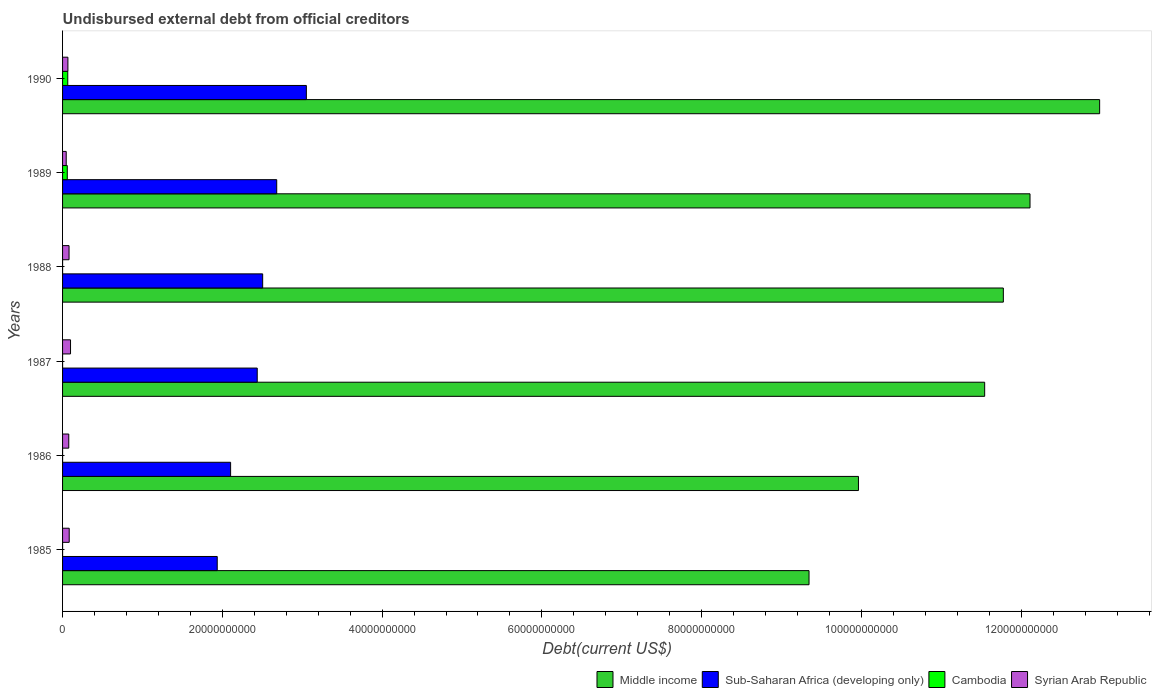How many groups of bars are there?
Your answer should be very brief. 6. Are the number of bars per tick equal to the number of legend labels?
Provide a succinct answer. Yes. How many bars are there on the 3rd tick from the top?
Offer a terse response. 4. What is the label of the 6th group of bars from the top?
Provide a succinct answer. 1985. What is the total debt in Cambodia in 1985?
Keep it short and to the point. 1.03e+06. Across all years, what is the maximum total debt in Middle income?
Your answer should be very brief. 1.30e+11. Across all years, what is the minimum total debt in Middle income?
Offer a very short reply. 9.34e+1. In which year was the total debt in Cambodia maximum?
Ensure brevity in your answer.  1990. In which year was the total debt in Middle income minimum?
Ensure brevity in your answer.  1985. What is the total total debt in Syrian Arab Republic in the graph?
Your answer should be very brief. 4.54e+09. What is the difference between the total debt in Syrian Arab Republic in 1989 and that in 1990?
Make the answer very short. -2.12e+08. What is the difference between the total debt in Sub-Saharan Africa (developing only) in 1990 and the total debt in Middle income in 1987?
Give a very brief answer. -8.49e+1. What is the average total debt in Middle income per year?
Offer a terse response. 1.13e+11. In the year 1987, what is the difference between the total debt in Cambodia and total debt in Sub-Saharan Africa (developing only)?
Keep it short and to the point. -2.44e+1. In how many years, is the total debt in Cambodia greater than 96000000000 US$?
Ensure brevity in your answer.  0. What is the ratio of the total debt in Middle income in 1985 to that in 1986?
Provide a succinct answer. 0.94. Is the total debt in Sub-Saharan Africa (developing only) in 1986 less than that in 1990?
Your answer should be compact. Yes. Is the difference between the total debt in Cambodia in 1985 and 1988 greater than the difference between the total debt in Sub-Saharan Africa (developing only) in 1985 and 1988?
Ensure brevity in your answer.  Yes. What is the difference between the highest and the second highest total debt in Cambodia?
Your answer should be very brief. 6.14e+07. What is the difference between the highest and the lowest total debt in Middle income?
Provide a short and direct response. 3.64e+1. Is the sum of the total debt in Cambodia in 1988 and 1989 greater than the maximum total debt in Sub-Saharan Africa (developing only) across all years?
Your answer should be very brief. No. Is it the case that in every year, the sum of the total debt in Sub-Saharan Africa (developing only) and total debt in Syrian Arab Republic is greater than the sum of total debt in Middle income and total debt in Cambodia?
Your answer should be very brief. No. What does the 4th bar from the top in 1985 represents?
Your answer should be compact. Middle income. What does the 3rd bar from the bottom in 1986 represents?
Provide a short and direct response. Cambodia. How many bars are there?
Ensure brevity in your answer.  24. Are all the bars in the graph horizontal?
Offer a terse response. Yes. What is the difference between two consecutive major ticks on the X-axis?
Offer a very short reply. 2.00e+1. Where does the legend appear in the graph?
Your answer should be very brief. Bottom right. How many legend labels are there?
Your response must be concise. 4. What is the title of the graph?
Your response must be concise. Undisbursed external debt from official creditors. Does "Sudan" appear as one of the legend labels in the graph?
Your answer should be compact. No. What is the label or title of the X-axis?
Ensure brevity in your answer.  Debt(current US$). What is the label or title of the Y-axis?
Offer a terse response. Years. What is the Debt(current US$) of Middle income in 1985?
Provide a succinct answer. 9.34e+1. What is the Debt(current US$) of Sub-Saharan Africa (developing only) in 1985?
Ensure brevity in your answer.  1.94e+1. What is the Debt(current US$) in Cambodia in 1985?
Provide a short and direct response. 1.03e+06. What is the Debt(current US$) in Syrian Arab Republic in 1985?
Your response must be concise. 8.31e+08. What is the Debt(current US$) of Middle income in 1986?
Offer a very short reply. 9.96e+1. What is the Debt(current US$) of Sub-Saharan Africa (developing only) in 1986?
Make the answer very short. 2.10e+1. What is the Debt(current US$) of Cambodia in 1986?
Keep it short and to the point. 1.03e+06. What is the Debt(current US$) of Syrian Arab Republic in 1986?
Offer a very short reply. 7.76e+08. What is the Debt(current US$) in Middle income in 1987?
Your answer should be very brief. 1.15e+11. What is the Debt(current US$) of Sub-Saharan Africa (developing only) in 1987?
Make the answer very short. 2.44e+1. What is the Debt(current US$) of Cambodia in 1987?
Provide a short and direct response. 1.03e+06. What is the Debt(current US$) of Syrian Arab Republic in 1987?
Provide a succinct answer. 9.97e+08. What is the Debt(current US$) in Middle income in 1988?
Keep it short and to the point. 1.18e+11. What is the Debt(current US$) of Sub-Saharan Africa (developing only) in 1988?
Your answer should be very brief. 2.50e+1. What is the Debt(current US$) in Cambodia in 1988?
Provide a short and direct response. 1.03e+06. What is the Debt(current US$) in Syrian Arab Republic in 1988?
Give a very brief answer. 8.11e+08. What is the Debt(current US$) in Middle income in 1989?
Ensure brevity in your answer.  1.21e+11. What is the Debt(current US$) of Sub-Saharan Africa (developing only) in 1989?
Provide a short and direct response. 2.68e+1. What is the Debt(current US$) of Cambodia in 1989?
Provide a succinct answer. 5.90e+08. What is the Debt(current US$) of Syrian Arab Republic in 1989?
Your answer should be compact. 4.57e+08. What is the Debt(current US$) of Middle income in 1990?
Make the answer very short. 1.30e+11. What is the Debt(current US$) of Sub-Saharan Africa (developing only) in 1990?
Your answer should be very brief. 3.05e+1. What is the Debt(current US$) of Cambodia in 1990?
Your response must be concise. 6.51e+08. What is the Debt(current US$) in Syrian Arab Republic in 1990?
Give a very brief answer. 6.69e+08. Across all years, what is the maximum Debt(current US$) in Middle income?
Provide a short and direct response. 1.30e+11. Across all years, what is the maximum Debt(current US$) in Sub-Saharan Africa (developing only)?
Offer a very short reply. 3.05e+1. Across all years, what is the maximum Debt(current US$) in Cambodia?
Your response must be concise. 6.51e+08. Across all years, what is the maximum Debt(current US$) in Syrian Arab Republic?
Provide a short and direct response. 9.97e+08. Across all years, what is the minimum Debt(current US$) of Middle income?
Ensure brevity in your answer.  9.34e+1. Across all years, what is the minimum Debt(current US$) in Sub-Saharan Africa (developing only)?
Ensure brevity in your answer.  1.94e+1. Across all years, what is the minimum Debt(current US$) in Cambodia?
Provide a short and direct response. 1.03e+06. Across all years, what is the minimum Debt(current US$) in Syrian Arab Republic?
Make the answer very short. 4.57e+08. What is the total Debt(current US$) in Middle income in the graph?
Your response must be concise. 6.77e+11. What is the total Debt(current US$) of Sub-Saharan Africa (developing only) in the graph?
Provide a succinct answer. 1.47e+11. What is the total Debt(current US$) in Cambodia in the graph?
Your response must be concise. 1.24e+09. What is the total Debt(current US$) of Syrian Arab Republic in the graph?
Keep it short and to the point. 4.54e+09. What is the difference between the Debt(current US$) of Middle income in 1985 and that in 1986?
Keep it short and to the point. -6.19e+09. What is the difference between the Debt(current US$) of Sub-Saharan Africa (developing only) in 1985 and that in 1986?
Make the answer very short. -1.67e+09. What is the difference between the Debt(current US$) in Syrian Arab Republic in 1985 and that in 1986?
Provide a succinct answer. 5.51e+07. What is the difference between the Debt(current US$) of Middle income in 1985 and that in 1987?
Your response must be concise. -2.20e+1. What is the difference between the Debt(current US$) of Sub-Saharan Africa (developing only) in 1985 and that in 1987?
Give a very brief answer. -5.01e+09. What is the difference between the Debt(current US$) of Syrian Arab Republic in 1985 and that in 1987?
Make the answer very short. -1.66e+08. What is the difference between the Debt(current US$) in Middle income in 1985 and that in 1988?
Your answer should be compact. -2.43e+1. What is the difference between the Debt(current US$) in Sub-Saharan Africa (developing only) in 1985 and that in 1988?
Make the answer very short. -5.69e+09. What is the difference between the Debt(current US$) in Syrian Arab Republic in 1985 and that in 1988?
Your response must be concise. 2.02e+07. What is the difference between the Debt(current US$) of Middle income in 1985 and that in 1989?
Offer a terse response. -2.77e+1. What is the difference between the Debt(current US$) in Sub-Saharan Africa (developing only) in 1985 and that in 1989?
Give a very brief answer. -7.45e+09. What is the difference between the Debt(current US$) of Cambodia in 1985 and that in 1989?
Your answer should be very brief. -5.89e+08. What is the difference between the Debt(current US$) in Syrian Arab Republic in 1985 and that in 1989?
Ensure brevity in your answer.  3.75e+08. What is the difference between the Debt(current US$) of Middle income in 1985 and that in 1990?
Keep it short and to the point. -3.64e+1. What is the difference between the Debt(current US$) of Sub-Saharan Africa (developing only) in 1985 and that in 1990?
Offer a very short reply. -1.12e+1. What is the difference between the Debt(current US$) of Cambodia in 1985 and that in 1990?
Give a very brief answer. -6.50e+08. What is the difference between the Debt(current US$) in Syrian Arab Republic in 1985 and that in 1990?
Give a very brief answer. 1.62e+08. What is the difference between the Debt(current US$) of Middle income in 1986 and that in 1987?
Your answer should be very brief. -1.58e+1. What is the difference between the Debt(current US$) of Sub-Saharan Africa (developing only) in 1986 and that in 1987?
Your response must be concise. -3.33e+09. What is the difference between the Debt(current US$) of Cambodia in 1986 and that in 1987?
Ensure brevity in your answer.  0. What is the difference between the Debt(current US$) of Syrian Arab Republic in 1986 and that in 1987?
Keep it short and to the point. -2.21e+08. What is the difference between the Debt(current US$) in Middle income in 1986 and that in 1988?
Provide a succinct answer. -1.81e+1. What is the difference between the Debt(current US$) in Sub-Saharan Africa (developing only) in 1986 and that in 1988?
Provide a short and direct response. -4.01e+09. What is the difference between the Debt(current US$) of Cambodia in 1986 and that in 1988?
Give a very brief answer. 0. What is the difference between the Debt(current US$) in Syrian Arab Republic in 1986 and that in 1988?
Your answer should be very brief. -3.49e+07. What is the difference between the Debt(current US$) in Middle income in 1986 and that in 1989?
Offer a terse response. -2.15e+1. What is the difference between the Debt(current US$) of Sub-Saharan Africa (developing only) in 1986 and that in 1989?
Offer a terse response. -5.77e+09. What is the difference between the Debt(current US$) in Cambodia in 1986 and that in 1989?
Keep it short and to the point. -5.89e+08. What is the difference between the Debt(current US$) in Syrian Arab Republic in 1986 and that in 1989?
Your response must be concise. 3.20e+08. What is the difference between the Debt(current US$) of Middle income in 1986 and that in 1990?
Provide a succinct answer. -3.02e+1. What is the difference between the Debt(current US$) in Sub-Saharan Africa (developing only) in 1986 and that in 1990?
Give a very brief answer. -9.48e+09. What is the difference between the Debt(current US$) in Cambodia in 1986 and that in 1990?
Your answer should be compact. -6.50e+08. What is the difference between the Debt(current US$) in Syrian Arab Republic in 1986 and that in 1990?
Ensure brevity in your answer.  1.07e+08. What is the difference between the Debt(current US$) of Middle income in 1987 and that in 1988?
Offer a very short reply. -2.34e+09. What is the difference between the Debt(current US$) in Sub-Saharan Africa (developing only) in 1987 and that in 1988?
Make the answer very short. -6.80e+08. What is the difference between the Debt(current US$) in Syrian Arab Republic in 1987 and that in 1988?
Ensure brevity in your answer.  1.86e+08. What is the difference between the Debt(current US$) in Middle income in 1987 and that in 1989?
Your response must be concise. -5.68e+09. What is the difference between the Debt(current US$) of Sub-Saharan Africa (developing only) in 1987 and that in 1989?
Your answer should be compact. -2.44e+09. What is the difference between the Debt(current US$) of Cambodia in 1987 and that in 1989?
Make the answer very short. -5.89e+08. What is the difference between the Debt(current US$) of Syrian Arab Republic in 1987 and that in 1989?
Keep it short and to the point. 5.40e+08. What is the difference between the Debt(current US$) of Middle income in 1987 and that in 1990?
Your response must be concise. -1.44e+1. What is the difference between the Debt(current US$) of Sub-Saharan Africa (developing only) in 1987 and that in 1990?
Provide a short and direct response. -6.15e+09. What is the difference between the Debt(current US$) in Cambodia in 1987 and that in 1990?
Make the answer very short. -6.50e+08. What is the difference between the Debt(current US$) of Syrian Arab Republic in 1987 and that in 1990?
Give a very brief answer. 3.28e+08. What is the difference between the Debt(current US$) in Middle income in 1988 and that in 1989?
Offer a terse response. -3.34e+09. What is the difference between the Debt(current US$) of Sub-Saharan Africa (developing only) in 1988 and that in 1989?
Make the answer very short. -1.76e+09. What is the difference between the Debt(current US$) of Cambodia in 1988 and that in 1989?
Provide a succinct answer. -5.89e+08. What is the difference between the Debt(current US$) of Syrian Arab Republic in 1988 and that in 1989?
Your answer should be compact. 3.54e+08. What is the difference between the Debt(current US$) of Middle income in 1988 and that in 1990?
Your answer should be compact. -1.21e+1. What is the difference between the Debt(current US$) in Sub-Saharan Africa (developing only) in 1988 and that in 1990?
Your answer should be compact. -5.47e+09. What is the difference between the Debt(current US$) in Cambodia in 1988 and that in 1990?
Ensure brevity in your answer.  -6.50e+08. What is the difference between the Debt(current US$) of Syrian Arab Republic in 1988 and that in 1990?
Provide a short and direct response. 1.42e+08. What is the difference between the Debt(current US$) of Middle income in 1989 and that in 1990?
Provide a short and direct response. -8.72e+09. What is the difference between the Debt(current US$) in Sub-Saharan Africa (developing only) in 1989 and that in 1990?
Provide a succinct answer. -3.71e+09. What is the difference between the Debt(current US$) of Cambodia in 1989 and that in 1990?
Keep it short and to the point. -6.14e+07. What is the difference between the Debt(current US$) in Syrian Arab Republic in 1989 and that in 1990?
Your answer should be very brief. -2.12e+08. What is the difference between the Debt(current US$) of Middle income in 1985 and the Debt(current US$) of Sub-Saharan Africa (developing only) in 1986?
Offer a terse response. 7.24e+1. What is the difference between the Debt(current US$) of Middle income in 1985 and the Debt(current US$) of Cambodia in 1986?
Offer a terse response. 9.34e+1. What is the difference between the Debt(current US$) of Middle income in 1985 and the Debt(current US$) of Syrian Arab Republic in 1986?
Keep it short and to the point. 9.27e+1. What is the difference between the Debt(current US$) in Sub-Saharan Africa (developing only) in 1985 and the Debt(current US$) in Cambodia in 1986?
Provide a succinct answer. 1.94e+1. What is the difference between the Debt(current US$) of Sub-Saharan Africa (developing only) in 1985 and the Debt(current US$) of Syrian Arab Republic in 1986?
Your answer should be compact. 1.86e+1. What is the difference between the Debt(current US$) of Cambodia in 1985 and the Debt(current US$) of Syrian Arab Republic in 1986?
Offer a very short reply. -7.75e+08. What is the difference between the Debt(current US$) of Middle income in 1985 and the Debt(current US$) of Sub-Saharan Africa (developing only) in 1987?
Your answer should be compact. 6.91e+1. What is the difference between the Debt(current US$) of Middle income in 1985 and the Debt(current US$) of Cambodia in 1987?
Provide a succinct answer. 9.34e+1. What is the difference between the Debt(current US$) in Middle income in 1985 and the Debt(current US$) in Syrian Arab Republic in 1987?
Offer a terse response. 9.24e+1. What is the difference between the Debt(current US$) in Sub-Saharan Africa (developing only) in 1985 and the Debt(current US$) in Cambodia in 1987?
Make the answer very short. 1.94e+1. What is the difference between the Debt(current US$) in Sub-Saharan Africa (developing only) in 1985 and the Debt(current US$) in Syrian Arab Republic in 1987?
Provide a succinct answer. 1.84e+1. What is the difference between the Debt(current US$) of Cambodia in 1985 and the Debt(current US$) of Syrian Arab Republic in 1987?
Your response must be concise. -9.96e+08. What is the difference between the Debt(current US$) in Middle income in 1985 and the Debt(current US$) in Sub-Saharan Africa (developing only) in 1988?
Ensure brevity in your answer.  6.84e+1. What is the difference between the Debt(current US$) in Middle income in 1985 and the Debt(current US$) in Cambodia in 1988?
Offer a terse response. 9.34e+1. What is the difference between the Debt(current US$) of Middle income in 1985 and the Debt(current US$) of Syrian Arab Republic in 1988?
Your answer should be compact. 9.26e+1. What is the difference between the Debt(current US$) in Sub-Saharan Africa (developing only) in 1985 and the Debt(current US$) in Cambodia in 1988?
Provide a succinct answer. 1.94e+1. What is the difference between the Debt(current US$) of Sub-Saharan Africa (developing only) in 1985 and the Debt(current US$) of Syrian Arab Republic in 1988?
Ensure brevity in your answer.  1.86e+1. What is the difference between the Debt(current US$) of Cambodia in 1985 and the Debt(current US$) of Syrian Arab Republic in 1988?
Your answer should be compact. -8.10e+08. What is the difference between the Debt(current US$) of Middle income in 1985 and the Debt(current US$) of Sub-Saharan Africa (developing only) in 1989?
Make the answer very short. 6.66e+1. What is the difference between the Debt(current US$) in Middle income in 1985 and the Debt(current US$) in Cambodia in 1989?
Your response must be concise. 9.29e+1. What is the difference between the Debt(current US$) in Middle income in 1985 and the Debt(current US$) in Syrian Arab Republic in 1989?
Provide a succinct answer. 9.30e+1. What is the difference between the Debt(current US$) of Sub-Saharan Africa (developing only) in 1985 and the Debt(current US$) of Cambodia in 1989?
Ensure brevity in your answer.  1.88e+1. What is the difference between the Debt(current US$) of Sub-Saharan Africa (developing only) in 1985 and the Debt(current US$) of Syrian Arab Republic in 1989?
Ensure brevity in your answer.  1.89e+1. What is the difference between the Debt(current US$) of Cambodia in 1985 and the Debt(current US$) of Syrian Arab Republic in 1989?
Provide a succinct answer. -4.56e+08. What is the difference between the Debt(current US$) in Middle income in 1985 and the Debt(current US$) in Sub-Saharan Africa (developing only) in 1990?
Your answer should be compact. 6.29e+1. What is the difference between the Debt(current US$) of Middle income in 1985 and the Debt(current US$) of Cambodia in 1990?
Provide a short and direct response. 9.28e+1. What is the difference between the Debt(current US$) of Middle income in 1985 and the Debt(current US$) of Syrian Arab Republic in 1990?
Provide a succinct answer. 9.28e+1. What is the difference between the Debt(current US$) of Sub-Saharan Africa (developing only) in 1985 and the Debt(current US$) of Cambodia in 1990?
Offer a terse response. 1.87e+1. What is the difference between the Debt(current US$) of Sub-Saharan Africa (developing only) in 1985 and the Debt(current US$) of Syrian Arab Republic in 1990?
Keep it short and to the point. 1.87e+1. What is the difference between the Debt(current US$) in Cambodia in 1985 and the Debt(current US$) in Syrian Arab Republic in 1990?
Ensure brevity in your answer.  -6.68e+08. What is the difference between the Debt(current US$) of Middle income in 1986 and the Debt(current US$) of Sub-Saharan Africa (developing only) in 1987?
Offer a terse response. 7.53e+1. What is the difference between the Debt(current US$) in Middle income in 1986 and the Debt(current US$) in Cambodia in 1987?
Ensure brevity in your answer.  9.96e+1. What is the difference between the Debt(current US$) in Middle income in 1986 and the Debt(current US$) in Syrian Arab Republic in 1987?
Ensure brevity in your answer.  9.86e+1. What is the difference between the Debt(current US$) of Sub-Saharan Africa (developing only) in 1986 and the Debt(current US$) of Cambodia in 1987?
Make the answer very short. 2.10e+1. What is the difference between the Debt(current US$) of Sub-Saharan Africa (developing only) in 1986 and the Debt(current US$) of Syrian Arab Republic in 1987?
Make the answer very short. 2.00e+1. What is the difference between the Debt(current US$) in Cambodia in 1986 and the Debt(current US$) in Syrian Arab Republic in 1987?
Make the answer very short. -9.96e+08. What is the difference between the Debt(current US$) in Middle income in 1986 and the Debt(current US$) in Sub-Saharan Africa (developing only) in 1988?
Offer a terse response. 7.46e+1. What is the difference between the Debt(current US$) of Middle income in 1986 and the Debt(current US$) of Cambodia in 1988?
Offer a terse response. 9.96e+1. What is the difference between the Debt(current US$) in Middle income in 1986 and the Debt(current US$) in Syrian Arab Republic in 1988?
Ensure brevity in your answer.  9.88e+1. What is the difference between the Debt(current US$) in Sub-Saharan Africa (developing only) in 1986 and the Debt(current US$) in Cambodia in 1988?
Keep it short and to the point. 2.10e+1. What is the difference between the Debt(current US$) of Sub-Saharan Africa (developing only) in 1986 and the Debt(current US$) of Syrian Arab Republic in 1988?
Keep it short and to the point. 2.02e+1. What is the difference between the Debt(current US$) of Cambodia in 1986 and the Debt(current US$) of Syrian Arab Republic in 1988?
Offer a very short reply. -8.10e+08. What is the difference between the Debt(current US$) in Middle income in 1986 and the Debt(current US$) in Sub-Saharan Africa (developing only) in 1989?
Make the answer very short. 7.28e+1. What is the difference between the Debt(current US$) of Middle income in 1986 and the Debt(current US$) of Cambodia in 1989?
Provide a succinct answer. 9.90e+1. What is the difference between the Debt(current US$) of Middle income in 1986 and the Debt(current US$) of Syrian Arab Republic in 1989?
Offer a terse response. 9.92e+1. What is the difference between the Debt(current US$) of Sub-Saharan Africa (developing only) in 1986 and the Debt(current US$) of Cambodia in 1989?
Your answer should be very brief. 2.04e+1. What is the difference between the Debt(current US$) of Sub-Saharan Africa (developing only) in 1986 and the Debt(current US$) of Syrian Arab Republic in 1989?
Offer a terse response. 2.06e+1. What is the difference between the Debt(current US$) of Cambodia in 1986 and the Debt(current US$) of Syrian Arab Republic in 1989?
Make the answer very short. -4.56e+08. What is the difference between the Debt(current US$) of Middle income in 1986 and the Debt(current US$) of Sub-Saharan Africa (developing only) in 1990?
Give a very brief answer. 6.91e+1. What is the difference between the Debt(current US$) of Middle income in 1986 and the Debt(current US$) of Cambodia in 1990?
Your answer should be very brief. 9.90e+1. What is the difference between the Debt(current US$) of Middle income in 1986 and the Debt(current US$) of Syrian Arab Republic in 1990?
Keep it short and to the point. 9.90e+1. What is the difference between the Debt(current US$) of Sub-Saharan Africa (developing only) in 1986 and the Debt(current US$) of Cambodia in 1990?
Provide a succinct answer. 2.04e+1. What is the difference between the Debt(current US$) of Sub-Saharan Africa (developing only) in 1986 and the Debt(current US$) of Syrian Arab Republic in 1990?
Your answer should be very brief. 2.04e+1. What is the difference between the Debt(current US$) of Cambodia in 1986 and the Debt(current US$) of Syrian Arab Republic in 1990?
Make the answer very short. -6.68e+08. What is the difference between the Debt(current US$) of Middle income in 1987 and the Debt(current US$) of Sub-Saharan Africa (developing only) in 1988?
Keep it short and to the point. 9.04e+1. What is the difference between the Debt(current US$) in Middle income in 1987 and the Debt(current US$) in Cambodia in 1988?
Make the answer very short. 1.15e+11. What is the difference between the Debt(current US$) of Middle income in 1987 and the Debt(current US$) of Syrian Arab Republic in 1988?
Ensure brevity in your answer.  1.15e+11. What is the difference between the Debt(current US$) of Sub-Saharan Africa (developing only) in 1987 and the Debt(current US$) of Cambodia in 1988?
Ensure brevity in your answer.  2.44e+1. What is the difference between the Debt(current US$) of Sub-Saharan Africa (developing only) in 1987 and the Debt(current US$) of Syrian Arab Republic in 1988?
Provide a short and direct response. 2.36e+1. What is the difference between the Debt(current US$) of Cambodia in 1987 and the Debt(current US$) of Syrian Arab Republic in 1988?
Offer a terse response. -8.10e+08. What is the difference between the Debt(current US$) of Middle income in 1987 and the Debt(current US$) of Sub-Saharan Africa (developing only) in 1989?
Provide a short and direct response. 8.86e+1. What is the difference between the Debt(current US$) in Middle income in 1987 and the Debt(current US$) in Cambodia in 1989?
Keep it short and to the point. 1.15e+11. What is the difference between the Debt(current US$) in Middle income in 1987 and the Debt(current US$) in Syrian Arab Republic in 1989?
Provide a short and direct response. 1.15e+11. What is the difference between the Debt(current US$) of Sub-Saharan Africa (developing only) in 1987 and the Debt(current US$) of Cambodia in 1989?
Provide a short and direct response. 2.38e+1. What is the difference between the Debt(current US$) in Sub-Saharan Africa (developing only) in 1987 and the Debt(current US$) in Syrian Arab Republic in 1989?
Provide a short and direct response. 2.39e+1. What is the difference between the Debt(current US$) in Cambodia in 1987 and the Debt(current US$) in Syrian Arab Republic in 1989?
Offer a terse response. -4.56e+08. What is the difference between the Debt(current US$) in Middle income in 1987 and the Debt(current US$) in Sub-Saharan Africa (developing only) in 1990?
Give a very brief answer. 8.49e+1. What is the difference between the Debt(current US$) of Middle income in 1987 and the Debt(current US$) of Cambodia in 1990?
Provide a succinct answer. 1.15e+11. What is the difference between the Debt(current US$) of Middle income in 1987 and the Debt(current US$) of Syrian Arab Republic in 1990?
Ensure brevity in your answer.  1.15e+11. What is the difference between the Debt(current US$) in Sub-Saharan Africa (developing only) in 1987 and the Debt(current US$) in Cambodia in 1990?
Make the answer very short. 2.37e+1. What is the difference between the Debt(current US$) of Sub-Saharan Africa (developing only) in 1987 and the Debt(current US$) of Syrian Arab Republic in 1990?
Offer a very short reply. 2.37e+1. What is the difference between the Debt(current US$) in Cambodia in 1987 and the Debt(current US$) in Syrian Arab Republic in 1990?
Give a very brief answer. -6.68e+08. What is the difference between the Debt(current US$) of Middle income in 1988 and the Debt(current US$) of Sub-Saharan Africa (developing only) in 1989?
Make the answer very short. 9.10e+1. What is the difference between the Debt(current US$) of Middle income in 1988 and the Debt(current US$) of Cambodia in 1989?
Ensure brevity in your answer.  1.17e+11. What is the difference between the Debt(current US$) of Middle income in 1988 and the Debt(current US$) of Syrian Arab Republic in 1989?
Keep it short and to the point. 1.17e+11. What is the difference between the Debt(current US$) of Sub-Saharan Africa (developing only) in 1988 and the Debt(current US$) of Cambodia in 1989?
Provide a succinct answer. 2.45e+1. What is the difference between the Debt(current US$) of Sub-Saharan Africa (developing only) in 1988 and the Debt(current US$) of Syrian Arab Republic in 1989?
Give a very brief answer. 2.46e+1. What is the difference between the Debt(current US$) of Cambodia in 1988 and the Debt(current US$) of Syrian Arab Republic in 1989?
Provide a short and direct response. -4.56e+08. What is the difference between the Debt(current US$) in Middle income in 1988 and the Debt(current US$) in Sub-Saharan Africa (developing only) in 1990?
Your answer should be compact. 8.72e+1. What is the difference between the Debt(current US$) in Middle income in 1988 and the Debt(current US$) in Cambodia in 1990?
Your answer should be compact. 1.17e+11. What is the difference between the Debt(current US$) of Middle income in 1988 and the Debt(current US$) of Syrian Arab Republic in 1990?
Ensure brevity in your answer.  1.17e+11. What is the difference between the Debt(current US$) of Sub-Saharan Africa (developing only) in 1988 and the Debt(current US$) of Cambodia in 1990?
Your response must be concise. 2.44e+1. What is the difference between the Debt(current US$) in Sub-Saharan Africa (developing only) in 1988 and the Debt(current US$) in Syrian Arab Republic in 1990?
Keep it short and to the point. 2.44e+1. What is the difference between the Debt(current US$) in Cambodia in 1988 and the Debt(current US$) in Syrian Arab Republic in 1990?
Offer a terse response. -6.68e+08. What is the difference between the Debt(current US$) in Middle income in 1989 and the Debt(current US$) in Sub-Saharan Africa (developing only) in 1990?
Provide a succinct answer. 9.06e+1. What is the difference between the Debt(current US$) in Middle income in 1989 and the Debt(current US$) in Cambodia in 1990?
Your answer should be compact. 1.20e+11. What is the difference between the Debt(current US$) of Middle income in 1989 and the Debt(current US$) of Syrian Arab Republic in 1990?
Give a very brief answer. 1.20e+11. What is the difference between the Debt(current US$) of Sub-Saharan Africa (developing only) in 1989 and the Debt(current US$) of Cambodia in 1990?
Make the answer very short. 2.62e+1. What is the difference between the Debt(current US$) of Sub-Saharan Africa (developing only) in 1989 and the Debt(current US$) of Syrian Arab Republic in 1990?
Make the answer very short. 2.61e+1. What is the difference between the Debt(current US$) of Cambodia in 1989 and the Debt(current US$) of Syrian Arab Republic in 1990?
Keep it short and to the point. -7.92e+07. What is the average Debt(current US$) in Middle income per year?
Ensure brevity in your answer.  1.13e+11. What is the average Debt(current US$) in Sub-Saharan Africa (developing only) per year?
Your answer should be compact. 2.45e+1. What is the average Debt(current US$) of Cambodia per year?
Provide a succinct answer. 2.07e+08. What is the average Debt(current US$) in Syrian Arab Republic per year?
Offer a very short reply. 7.57e+08. In the year 1985, what is the difference between the Debt(current US$) of Middle income and Debt(current US$) of Sub-Saharan Africa (developing only)?
Your response must be concise. 7.41e+1. In the year 1985, what is the difference between the Debt(current US$) of Middle income and Debt(current US$) of Cambodia?
Ensure brevity in your answer.  9.34e+1. In the year 1985, what is the difference between the Debt(current US$) of Middle income and Debt(current US$) of Syrian Arab Republic?
Provide a succinct answer. 9.26e+1. In the year 1985, what is the difference between the Debt(current US$) in Sub-Saharan Africa (developing only) and Debt(current US$) in Cambodia?
Your answer should be very brief. 1.94e+1. In the year 1985, what is the difference between the Debt(current US$) of Sub-Saharan Africa (developing only) and Debt(current US$) of Syrian Arab Republic?
Give a very brief answer. 1.85e+1. In the year 1985, what is the difference between the Debt(current US$) of Cambodia and Debt(current US$) of Syrian Arab Republic?
Your answer should be compact. -8.30e+08. In the year 1986, what is the difference between the Debt(current US$) of Middle income and Debt(current US$) of Sub-Saharan Africa (developing only)?
Your answer should be very brief. 7.86e+1. In the year 1986, what is the difference between the Debt(current US$) of Middle income and Debt(current US$) of Cambodia?
Keep it short and to the point. 9.96e+1. In the year 1986, what is the difference between the Debt(current US$) in Middle income and Debt(current US$) in Syrian Arab Republic?
Ensure brevity in your answer.  9.89e+1. In the year 1986, what is the difference between the Debt(current US$) in Sub-Saharan Africa (developing only) and Debt(current US$) in Cambodia?
Provide a succinct answer. 2.10e+1. In the year 1986, what is the difference between the Debt(current US$) of Sub-Saharan Africa (developing only) and Debt(current US$) of Syrian Arab Republic?
Provide a short and direct response. 2.03e+1. In the year 1986, what is the difference between the Debt(current US$) of Cambodia and Debt(current US$) of Syrian Arab Republic?
Provide a short and direct response. -7.75e+08. In the year 1987, what is the difference between the Debt(current US$) of Middle income and Debt(current US$) of Sub-Saharan Africa (developing only)?
Your response must be concise. 9.11e+1. In the year 1987, what is the difference between the Debt(current US$) of Middle income and Debt(current US$) of Cambodia?
Keep it short and to the point. 1.15e+11. In the year 1987, what is the difference between the Debt(current US$) in Middle income and Debt(current US$) in Syrian Arab Republic?
Give a very brief answer. 1.14e+11. In the year 1987, what is the difference between the Debt(current US$) in Sub-Saharan Africa (developing only) and Debt(current US$) in Cambodia?
Offer a terse response. 2.44e+1. In the year 1987, what is the difference between the Debt(current US$) of Sub-Saharan Africa (developing only) and Debt(current US$) of Syrian Arab Republic?
Your answer should be very brief. 2.34e+1. In the year 1987, what is the difference between the Debt(current US$) in Cambodia and Debt(current US$) in Syrian Arab Republic?
Make the answer very short. -9.96e+08. In the year 1988, what is the difference between the Debt(current US$) of Middle income and Debt(current US$) of Sub-Saharan Africa (developing only)?
Give a very brief answer. 9.27e+1. In the year 1988, what is the difference between the Debt(current US$) in Middle income and Debt(current US$) in Cambodia?
Offer a terse response. 1.18e+11. In the year 1988, what is the difference between the Debt(current US$) in Middle income and Debt(current US$) in Syrian Arab Republic?
Give a very brief answer. 1.17e+11. In the year 1988, what is the difference between the Debt(current US$) of Sub-Saharan Africa (developing only) and Debt(current US$) of Cambodia?
Keep it short and to the point. 2.50e+1. In the year 1988, what is the difference between the Debt(current US$) in Sub-Saharan Africa (developing only) and Debt(current US$) in Syrian Arab Republic?
Your answer should be very brief. 2.42e+1. In the year 1988, what is the difference between the Debt(current US$) in Cambodia and Debt(current US$) in Syrian Arab Republic?
Provide a short and direct response. -8.10e+08. In the year 1989, what is the difference between the Debt(current US$) of Middle income and Debt(current US$) of Sub-Saharan Africa (developing only)?
Give a very brief answer. 9.43e+1. In the year 1989, what is the difference between the Debt(current US$) in Middle income and Debt(current US$) in Cambodia?
Provide a succinct answer. 1.21e+11. In the year 1989, what is the difference between the Debt(current US$) in Middle income and Debt(current US$) in Syrian Arab Republic?
Your answer should be very brief. 1.21e+11. In the year 1989, what is the difference between the Debt(current US$) of Sub-Saharan Africa (developing only) and Debt(current US$) of Cambodia?
Provide a succinct answer. 2.62e+1. In the year 1989, what is the difference between the Debt(current US$) in Sub-Saharan Africa (developing only) and Debt(current US$) in Syrian Arab Republic?
Provide a short and direct response. 2.64e+1. In the year 1989, what is the difference between the Debt(current US$) of Cambodia and Debt(current US$) of Syrian Arab Republic?
Provide a succinct answer. 1.33e+08. In the year 1990, what is the difference between the Debt(current US$) in Middle income and Debt(current US$) in Sub-Saharan Africa (developing only)?
Provide a succinct answer. 9.93e+1. In the year 1990, what is the difference between the Debt(current US$) in Middle income and Debt(current US$) in Cambodia?
Your response must be concise. 1.29e+11. In the year 1990, what is the difference between the Debt(current US$) in Middle income and Debt(current US$) in Syrian Arab Republic?
Make the answer very short. 1.29e+11. In the year 1990, what is the difference between the Debt(current US$) of Sub-Saharan Africa (developing only) and Debt(current US$) of Cambodia?
Your answer should be very brief. 2.99e+1. In the year 1990, what is the difference between the Debt(current US$) of Sub-Saharan Africa (developing only) and Debt(current US$) of Syrian Arab Republic?
Your response must be concise. 2.98e+1. In the year 1990, what is the difference between the Debt(current US$) of Cambodia and Debt(current US$) of Syrian Arab Republic?
Your answer should be very brief. -1.78e+07. What is the ratio of the Debt(current US$) of Middle income in 1985 to that in 1986?
Your response must be concise. 0.94. What is the ratio of the Debt(current US$) in Sub-Saharan Africa (developing only) in 1985 to that in 1986?
Your answer should be very brief. 0.92. What is the ratio of the Debt(current US$) in Syrian Arab Republic in 1985 to that in 1986?
Ensure brevity in your answer.  1.07. What is the ratio of the Debt(current US$) of Middle income in 1985 to that in 1987?
Your answer should be very brief. 0.81. What is the ratio of the Debt(current US$) in Sub-Saharan Africa (developing only) in 1985 to that in 1987?
Your answer should be very brief. 0.79. What is the ratio of the Debt(current US$) in Syrian Arab Republic in 1985 to that in 1987?
Your response must be concise. 0.83. What is the ratio of the Debt(current US$) of Middle income in 1985 to that in 1988?
Ensure brevity in your answer.  0.79. What is the ratio of the Debt(current US$) of Sub-Saharan Africa (developing only) in 1985 to that in 1988?
Offer a very short reply. 0.77. What is the ratio of the Debt(current US$) of Syrian Arab Republic in 1985 to that in 1988?
Give a very brief answer. 1.02. What is the ratio of the Debt(current US$) in Middle income in 1985 to that in 1989?
Your answer should be compact. 0.77. What is the ratio of the Debt(current US$) in Sub-Saharan Africa (developing only) in 1985 to that in 1989?
Offer a very short reply. 0.72. What is the ratio of the Debt(current US$) of Cambodia in 1985 to that in 1989?
Ensure brevity in your answer.  0. What is the ratio of the Debt(current US$) in Syrian Arab Republic in 1985 to that in 1989?
Your answer should be very brief. 1.82. What is the ratio of the Debt(current US$) of Middle income in 1985 to that in 1990?
Ensure brevity in your answer.  0.72. What is the ratio of the Debt(current US$) in Sub-Saharan Africa (developing only) in 1985 to that in 1990?
Ensure brevity in your answer.  0.63. What is the ratio of the Debt(current US$) in Cambodia in 1985 to that in 1990?
Your answer should be compact. 0. What is the ratio of the Debt(current US$) of Syrian Arab Republic in 1985 to that in 1990?
Offer a terse response. 1.24. What is the ratio of the Debt(current US$) of Middle income in 1986 to that in 1987?
Ensure brevity in your answer.  0.86. What is the ratio of the Debt(current US$) of Sub-Saharan Africa (developing only) in 1986 to that in 1987?
Provide a short and direct response. 0.86. What is the ratio of the Debt(current US$) in Syrian Arab Republic in 1986 to that in 1987?
Ensure brevity in your answer.  0.78. What is the ratio of the Debt(current US$) in Middle income in 1986 to that in 1988?
Give a very brief answer. 0.85. What is the ratio of the Debt(current US$) in Sub-Saharan Africa (developing only) in 1986 to that in 1988?
Give a very brief answer. 0.84. What is the ratio of the Debt(current US$) in Syrian Arab Republic in 1986 to that in 1988?
Offer a very short reply. 0.96. What is the ratio of the Debt(current US$) in Middle income in 1986 to that in 1989?
Your answer should be compact. 0.82. What is the ratio of the Debt(current US$) of Sub-Saharan Africa (developing only) in 1986 to that in 1989?
Ensure brevity in your answer.  0.78. What is the ratio of the Debt(current US$) in Cambodia in 1986 to that in 1989?
Keep it short and to the point. 0. What is the ratio of the Debt(current US$) in Syrian Arab Republic in 1986 to that in 1989?
Offer a very short reply. 1.7. What is the ratio of the Debt(current US$) in Middle income in 1986 to that in 1990?
Your response must be concise. 0.77. What is the ratio of the Debt(current US$) in Sub-Saharan Africa (developing only) in 1986 to that in 1990?
Your answer should be compact. 0.69. What is the ratio of the Debt(current US$) of Cambodia in 1986 to that in 1990?
Provide a succinct answer. 0. What is the ratio of the Debt(current US$) of Syrian Arab Republic in 1986 to that in 1990?
Your response must be concise. 1.16. What is the ratio of the Debt(current US$) in Middle income in 1987 to that in 1988?
Provide a succinct answer. 0.98. What is the ratio of the Debt(current US$) in Sub-Saharan Africa (developing only) in 1987 to that in 1988?
Keep it short and to the point. 0.97. What is the ratio of the Debt(current US$) of Cambodia in 1987 to that in 1988?
Your answer should be compact. 1. What is the ratio of the Debt(current US$) of Syrian Arab Republic in 1987 to that in 1988?
Give a very brief answer. 1.23. What is the ratio of the Debt(current US$) in Middle income in 1987 to that in 1989?
Keep it short and to the point. 0.95. What is the ratio of the Debt(current US$) in Sub-Saharan Africa (developing only) in 1987 to that in 1989?
Offer a terse response. 0.91. What is the ratio of the Debt(current US$) of Cambodia in 1987 to that in 1989?
Provide a succinct answer. 0. What is the ratio of the Debt(current US$) in Syrian Arab Republic in 1987 to that in 1989?
Offer a very short reply. 2.18. What is the ratio of the Debt(current US$) in Middle income in 1987 to that in 1990?
Offer a terse response. 0.89. What is the ratio of the Debt(current US$) of Sub-Saharan Africa (developing only) in 1987 to that in 1990?
Offer a very short reply. 0.8. What is the ratio of the Debt(current US$) in Cambodia in 1987 to that in 1990?
Your response must be concise. 0. What is the ratio of the Debt(current US$) in Syrian Arab Republic in 1987 to that in 1990?
Make the answer very short. 1.49. What is the ratio of the Debt(current US$) of Middle income in 1988 to that in 1989?
Make the answer very short. 0.97. What is the ratio of the Debt(current US$) of Sub-Saharan Africa (developing only) in 1988 to that in 1989?
Ensure brevity in your answer.  0.93. What is the ratio of the Debt(current US$) of Cambodia in 1988 to that in 1989?
Offer a terse response. 0. What is the ratio of the Debt(current US$) of Syrian Arab Republic in 1988 to that in 1989?
Offer a very short reply. 1.78. What is the ratio of the Debt(current US$) of Middle income in 1988 to that in 1990?
Offer a very short reply. 0.91. What is the ratio of the Debt(current US$) of Sub-Saharan Africa (developing only) in 1988 to that in 1990?
Provide a succinct answer. 0.82. What is the ratio of the Debt(current US$) in Cambodia in 1988 to that in 1990?
Your answer should be very brief. 0. What is the ratio of the Debt(current US$) in Syrian Arab Republic in 1988 to that in 1990?
Keep it short and to the point. 1.21. What is the ratio of the Debt(current US$) in Middle income in 1989 to that in 1990?
Provide a succinct answer. 0.93. What is the ratio of the Debt(current US$) of Sub-Saharan Africa (developing only) in 1989 to that in 1990?
Ensure brevity in your answer.  0.88. What is the ratio of the Debt(current US$) in Cambodia in 1989 to that in 1990?
Provide a short and direct response. 0.91. What is the ratio of the Debt(current US$) in Syrian Arab Republic in 1989 to that in 1990?
Provide a succinct answer. 0.68. What is the difference between the highest and the second highest Debt(current US$) of Middle income?
Provide a succinct answer. 8.72e+09. What is the difference between the highest and the second highest Debt(current US$) in Sub-Saharan Africa (developing only)?
Provide a succinct answer. 3.71e+09. What is the difference between the highest and the second highest Debt(current US$) of Cambodia?
Ensure brevity in your answer.  6.14e+07. What is the difference between the highest and the second highest Debt(current US$) in Syrian Arab Republic?
Give a very brief answer. 1.66e+08. What is the difference between the highest and the lowest Debt(current US$) of Middle income?
Provide a short and direct response. 3.64e+1. What is the difference between the highest and the lowest Debt(current US$) of Sub-Saharan Africa (developing only)?
Keep it short and to the point. 1.12e+1. What is the difference between the highest and the lowest Debt(current US$) of Cambodia?
Your response must be concise. 6.50e+08. What is the difference between the highest and the lowest Debt(current US$) of Syrian Arab Republic?
Provide a short and direct response. 5.40e+08. 